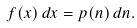Convert formula to latex. <formula><loc_0><loc_0><loc_500><loc_500>f ( x ) \, d x = p ( n ) \, d n .</formula> 